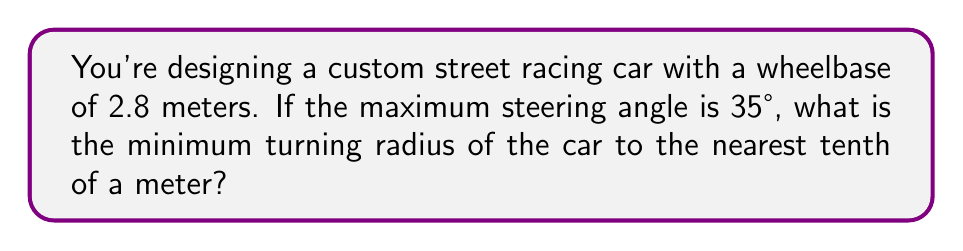Help me with this question. To solve this problem, we'll use the formula for the turning radius of a car:

$$R = \frac{L}{\sin(\theta)}$$

Where:
$R$ = turning radius
$L$ = wheelbase
$\theta$ = steering angle

Step 1: Identify the given values
$L = 2.8$ meters
$\theta = 35°$

Step 2: Substitute these values into the formula
$$R = \frac{2.8}{\sin(35°)}$$

Step 3: Calculate the sine of 35°
$\sin(35°) \approx 0.5736$

Step 4: Divide 2.8 by the sine value
$$R = \frac{2.8}{0.5736} \approx 4.8819$$

Step 5: Round to the nearest tenth
$R \approx 4.9$ meters

Therefore, the minimum turning radius of the custom street racing car is approximately 4.9 meters.
Answer: 4.9 meters 